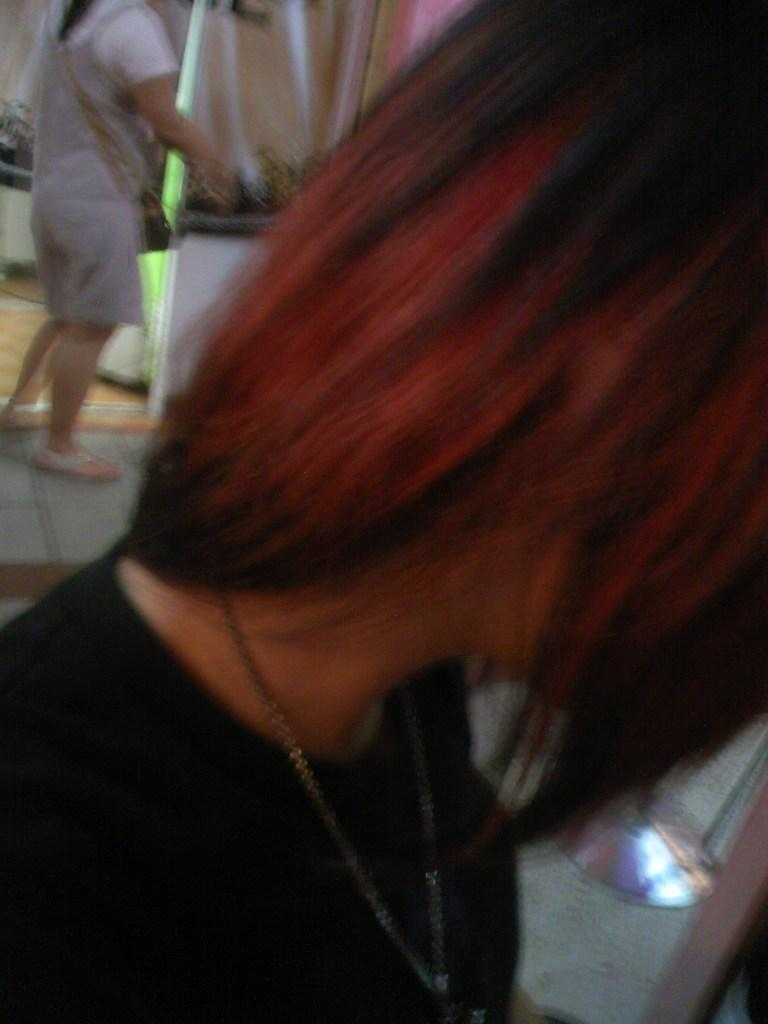How many people are in the image? There are two people in the image. What is one of the people doing in the image? One person is carrying a bag and standing on the floor. What can be seen in the background of the image? There are objects visible in the background of the image. What advice is the person carrying the bag giving to the other person in the image? There is no indication in the image that the person carrying the bag is giving advice to the other person. 